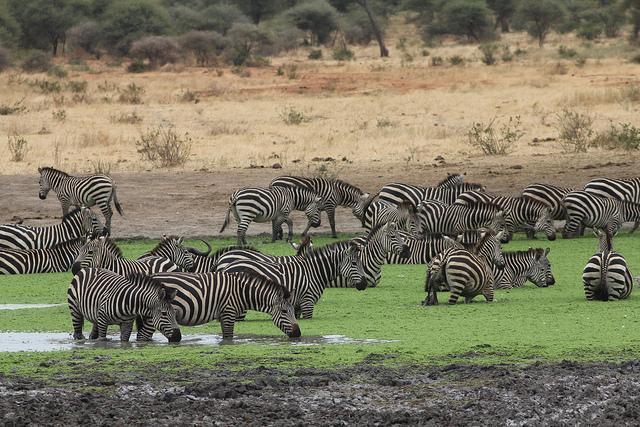How many zebras can you see?
Give a very brief answer. 11. How many of the kites are shaped like an iguana?
Give a very brief answer. 0. 